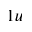<formula> <loc_0><loc_0><loc_500><loc_500>_ { 1 u }</formula> 